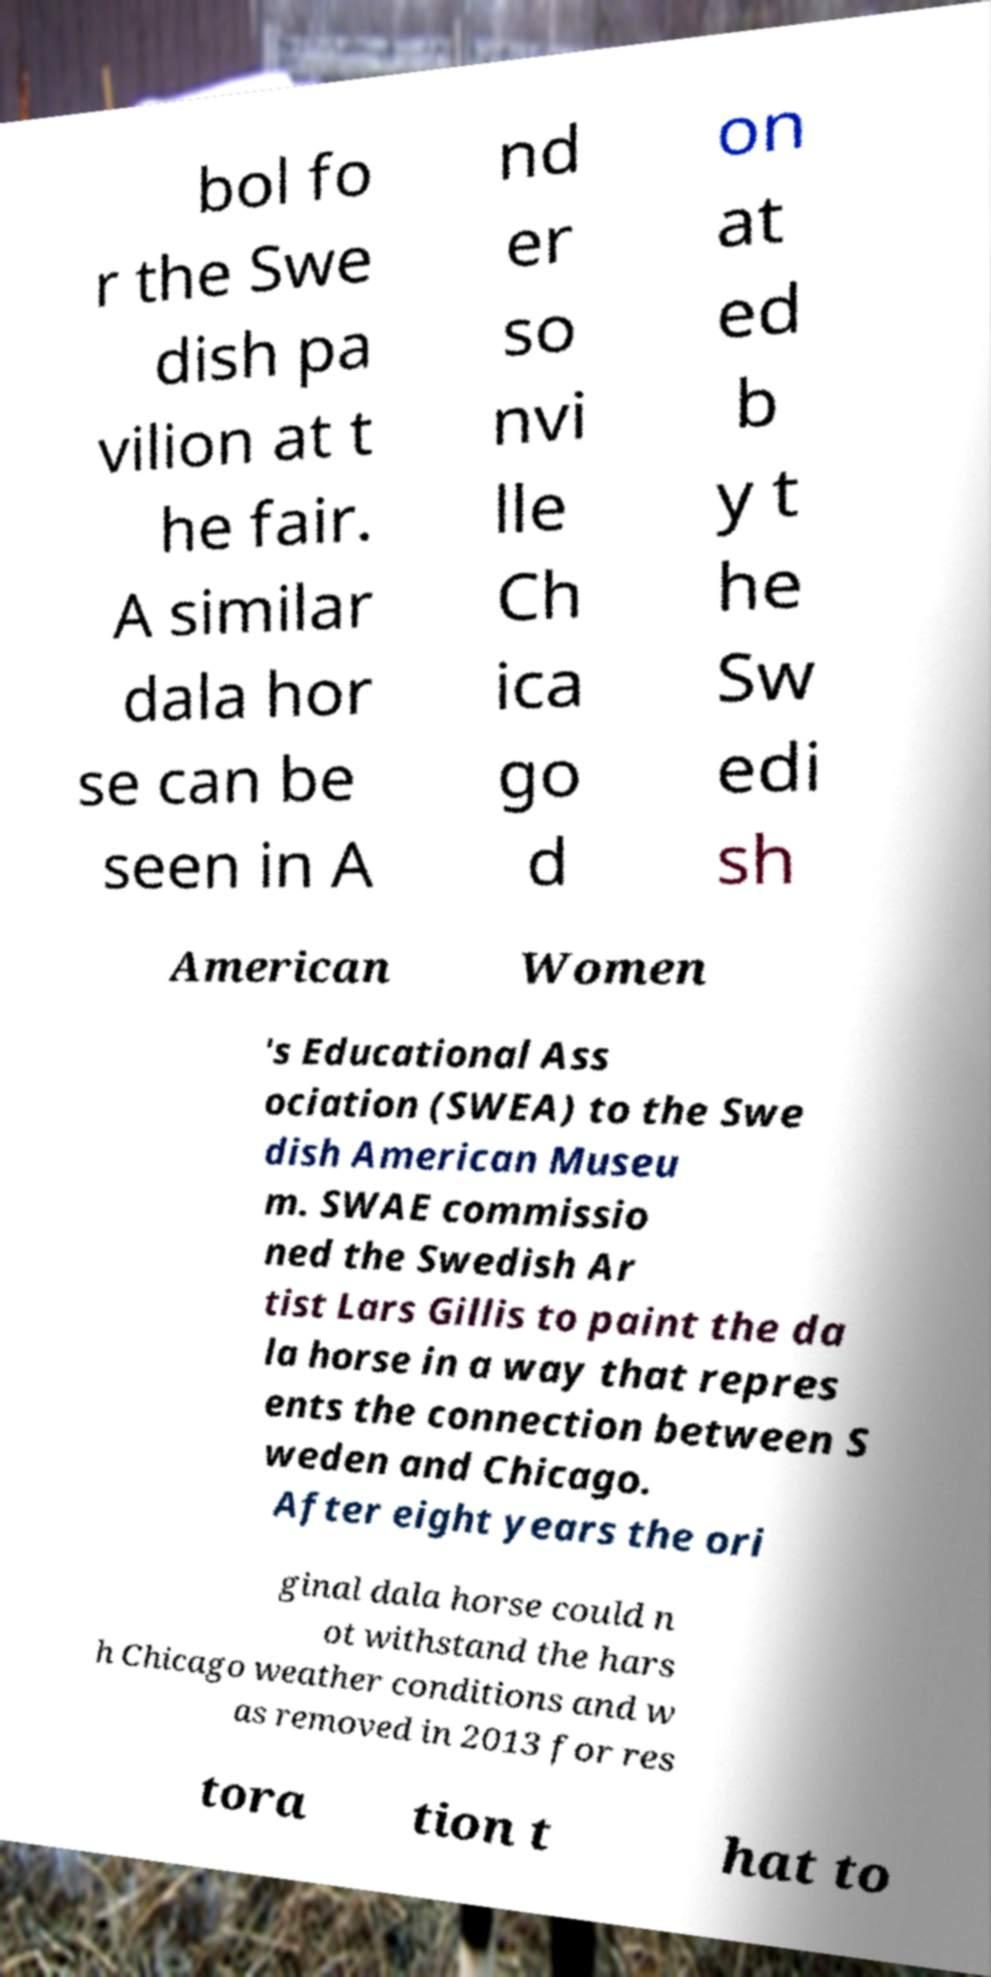Please read and relay the text visible in this image. What does it say? bol fo r the Swe dish pa vilion at t he fair. A similar dala hor se can be seen in A nd er so nvi lle Ch ica go d on at ed b y t he Sw edi sh American Women 's Educational Ass ociation (SWEA) to the Swe dish American Museu m. SWAE commissio ned the Swedish Ar tist Lars Gillis to paint the da la horse in a way that repres ents the connection between S weden and Chicago. After eight years the ori ginal dala horse could n ot withstand the hars h Chicago weather conditions and w as removed in 2013 for res tora tion t hat to 